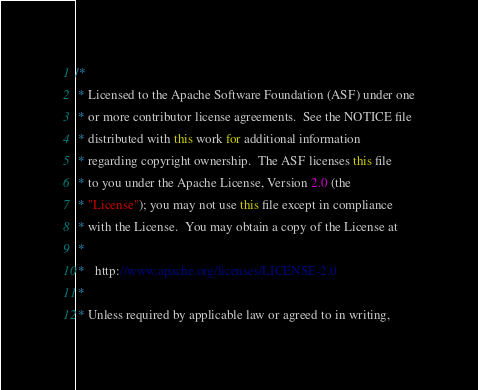<code> <loc_0><loc_0><loc_500><loc_500><_Java_>/*
 * Licensed to the Apache Software Foundation (ASF) under one
 * or more contributor license agreements.  See the NOTICE file
 * distributed with this work for additional information
 * regarding copyright ownership.  The ASF licenses this file
 * to you under the Apache License, Version 2.0 (the
 * "License"); you may not use this file except in compliance
 * with the License.  You may obtain a copy of the License at
 *
 *   http://www.apache.org/licenses/LICENSE-2.0
 *
 * Unless required by applicable law or agreed to in writing,</code> 